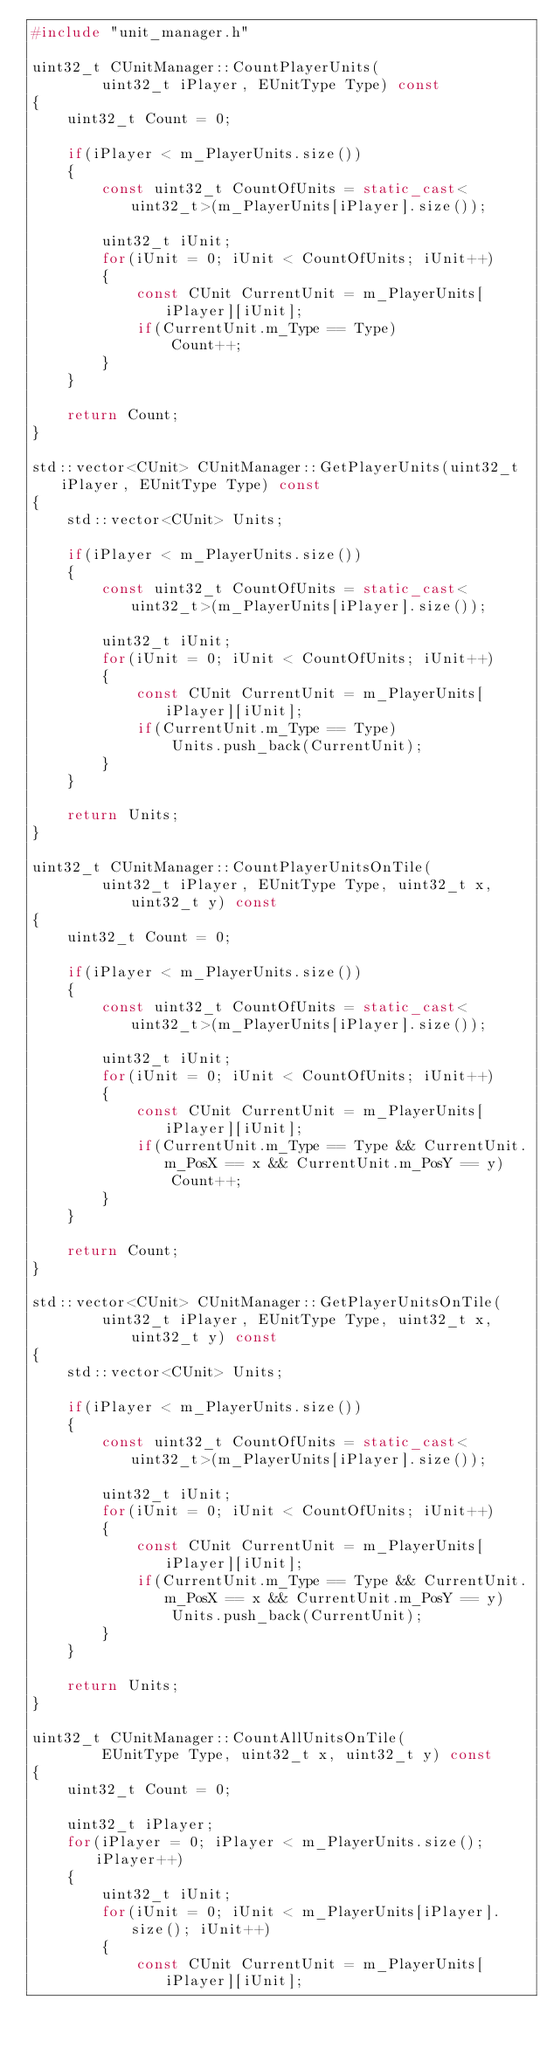<code> <loc_0><loc_0><loc_500><loc_500><_C++_>#include "unit_manager.h"

uint32_t CUnitManager::CountPlayerUnits(
        uint32_t iPlayer, EUnitType Type) const
{
    uint32_t Count = 0;

    if(iPlayer < m_PlayerUnits.size())
    {
        const uint32_t CountOfUnits = static_cast<uint32_t>(m_PlayerUnits[iPlayer].size());

        uint32_t iUnit;
        for(iUnit = 0; iUnit < CountOfUnits; iUnit++)
        {
            const CUnit CurrentUnit = m_PlayerUnits[iPlayer][iUnit];
            if(CurrentUnit.m_Type == Type)
                Count++;
        }
    }

    return Count;
}

std::vector<CUnit> CUnitManager::GetPlayerUnits(uint32_t iPlayer, EUnitType Type) const
{
    std::vector<CUnit> Units;

    if(iPlayer < m_PlayerUnits.size())
    {
        const uint32_t CountOfUnits = static_cast<uint32_t>(m_PlayerUnits[iPlayer].size());

        uint32_t iUnit;
        for(iUnit = 0; iUnit < CountOfUnits; iUnit++)
        {
            const CUnit CurrentUnit = m_PlayerUnits[iPlayer][iUnit];
            if(CurrentUnit.m_Type == Type)
                Units.push_back(CurrentUnit);
        }
    }

    return Units;
}

uint32_t CUnitManager::CountPlayerUnitsOnTile(
        uint32_t iPlayer, EUnitType Type, uint32_t x, uint32_t y) const
{
    uint32_t Count = 0;

    if(iPlayer < m_PlayerUnits.size())
    {
        const uint32_t CountOfUnits = static_cast<uint32_t>(m_PlayerUnits[iPlayer].size());

        uint32_t iUnit;
        for(iUnit = 0; iUnit < CountOfUnits; iUnit++)
        {
            const CUnit CurrentUnit = m_PlayerUnits[iPlayer][iUnit];
            if(CurrentUnit.m_Type == Type && CurrentUnit.m_PosX == x && CurrentUnit.m_PosY == y)
                Count++;
        }
    }

    return Count;
}

std::vector<CUnit> CUnitManager::GetPlayerUnitsOnTile(
        uint32_t iPlayer, EUnitType Type, uint32_t x, uint32_t y) const
{
    std::vector<CUnit> Units;

    if(iPlayer < m_PlayerUnits.size())
    {
        const uint32_t CountOfUnits = static_cast<uint32_t>(m_PlayerUnits[iPlayer].size());

        uint32_t iUnit;
        for(iUnit = 0; iUnit < CountOfUnits; iUnit++)
        {
            const CUnit CurrentUnit = m_PlayerUnits[iPlayer][iUnit];
            if(CurrentUnit.m_Type == Type && CurrentUnit.m_PosX == x && CurrentUnit.m_PosY == y)
                Units.push_back(CurrentUnit);
        }
    }

    return Units;
}

uint32_t CUnitManager::CountAllUnitsOnTile(
        EUnitType Type, uint32_t x, uint32_t y) const
{
    uint32_t Count = 0;

    uint32_t iPlayer;
    for(iPlayer = 0; iPlayer < m_PlayerUnits.size(); iPlayer++)
    {
        uint32_t iUnit;
        for(iUnit = 0; iUnit < m_PlayerUnits[iPlayer].size(); iUnit++)
        {
            const CUnit CurrentUnit = m_PlayerUnits[iPlayer][iUnit];</code> 